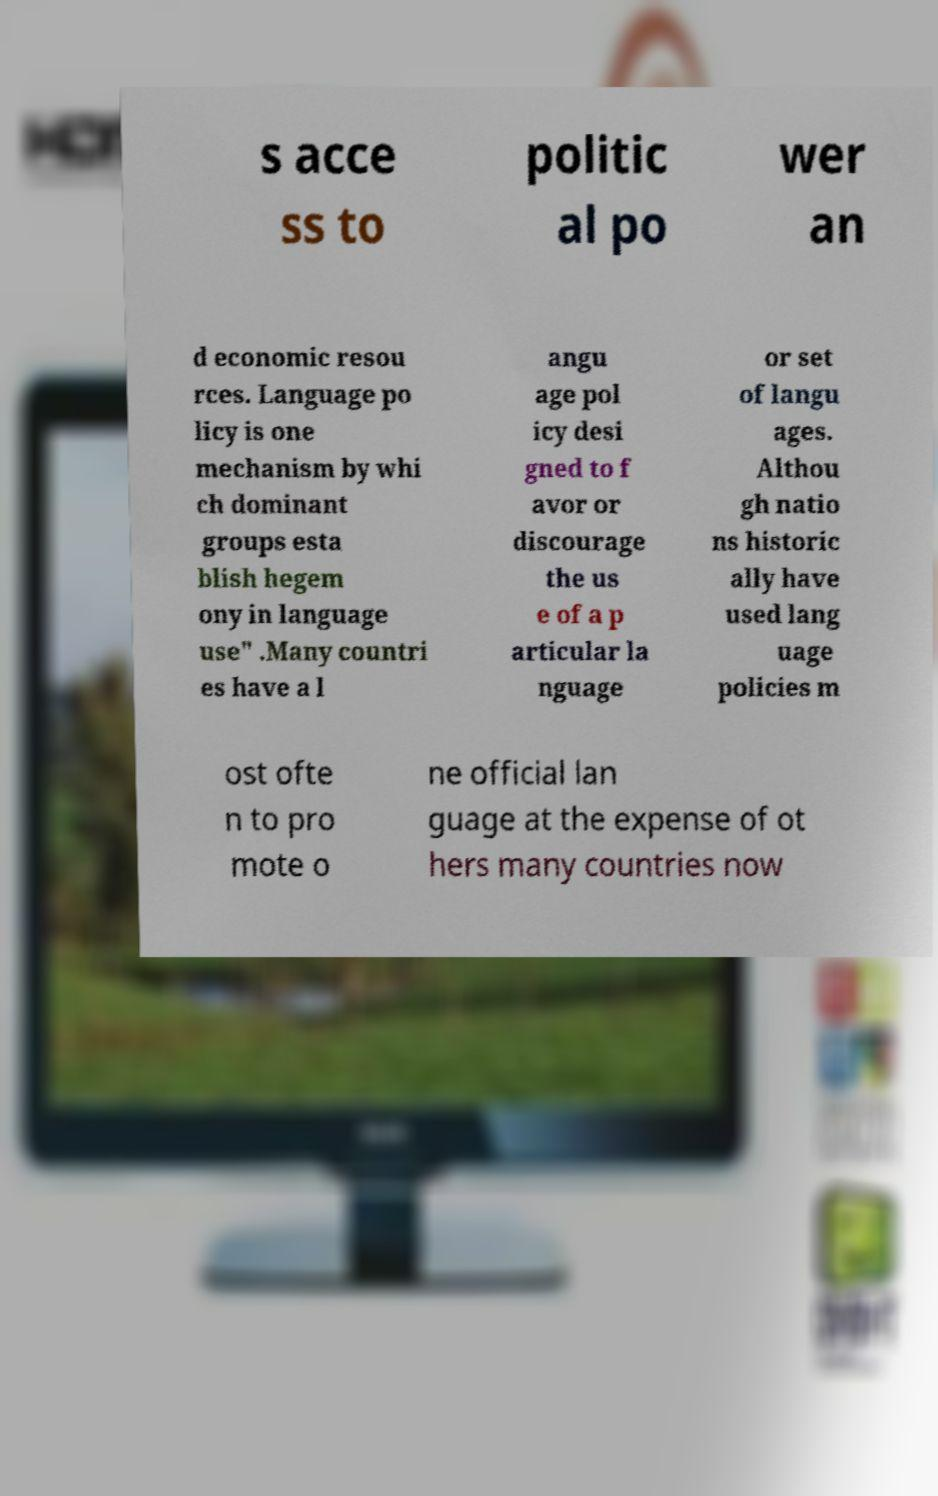Please read and relay the text visible in this image. What does it say? s acce ss to politic al po wer an d economic resou rces. Language po licy is one mechanism by whi ch dominant groups esta blish hegem ony in language use" .Many countri es have a l angu age pol icy desi gned to f avor or discourage the us e of a p articular la nguage or set of langu ages. Althou gh natio ns historic ally have used lang uage policies m ost ofte n to pro mote o ne official lan guage at the expense of ot hers many countries now 